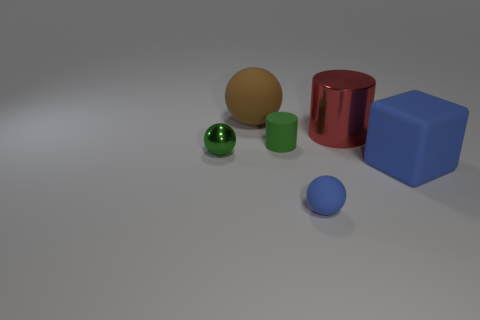Are there any other things that have the same shape as the large blue matte object?
Provide a short and direct response. No. There is a ball that is behind the small ball on the left side of the tiny blue ball; is there a metallic ball behind it?
Provide a succinct answer. No. Do the matte ball that is on the left side of the green cylinder and the red shiny cylinder have the same size?
Ensure brevity in your answer.  Yes. How many metallic balls have the same size as the red metallic cylinder?
Keep it short and to the point. 0. There is a object that is the same color as the tiny cylinder; what is its size?
Keep it short and to the point. Small. Is the small metallic thing the same color as the cube?
Offer a terse response. No. What is the shape of the red shiny thing?
Provide a succinct answer. Cylinder. Is there another sphere of the same color as the big sphere?
Your response must be concise. No. Are there more big matte balls right of the brown matte thing than green spheres?
Offer a very short reply. No. Do the big red thing and the tiny thing to the left of the brown thing have the same shape?
Provide a succinct answer. No. 